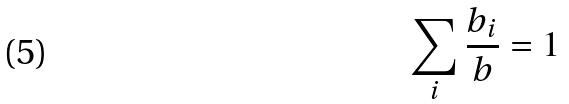Convert formula to latex. <formula><loc_0><loc_0><loc_500><loc_500>\sum _ { i } \frac { b _ { i } } { b } = 1</formula> 